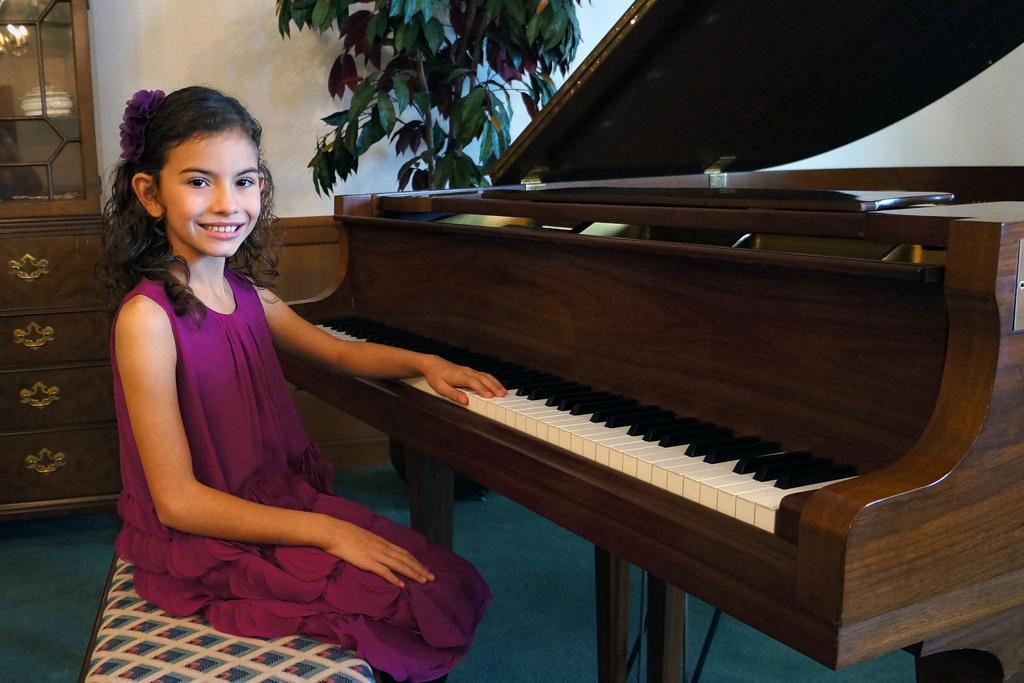Can you describe this image briefly? In this image there is a girl sitting in chair and playing piano and back ground there is cupboard , plant. 